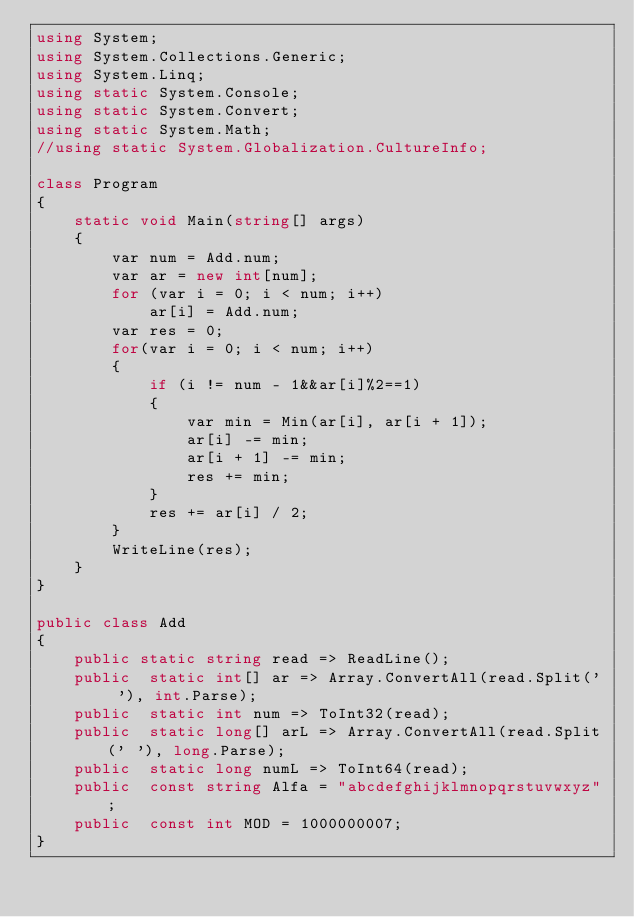Convert code to text. <code><loc_0><loc_0><loc_500><loc_500><_C#_>using System;
using System.Collections.Generic;
using System.Linq;
using static System.Console;
using static System.Convert;
using static System.Math;
//using static System.Globalization.CultureInfo;

class Program
{
    static void Main(string[] args)
    {
        var num = Add.num;
        var ar = new int[num];
        for (var i = 0; i < num; i++)
            ar[i] = Add.num;
        var res = 0;
        for(var i = 0; i < num; i++)
        {
            if (i != num - 1&&ar[i]%2==1)
            {
                var min = Min(ar[i], ar[i + 1]);
                ar[i] -= min;
                ar[i + 1] -= min;
                res += min;
            }
            res += ar[i] / 2;
        }
        WriteLine(res);
    }
}

public class Add
{
    public static string read => ReadLine();
    public  static int[] ar => Array.ConvertAll(read.Split(' '), int.Parse);
    public  static int num => ToInt32(read);
    public  static long[] arL => Array.ConvertAll(read.Split(' '), long.Parse);
    public  static long numL => ToInt64(read);
    public  const string Alfa = "abcdefghijklmnopqrstuvwxyz";
    public  const int MOD = 1000000007;
}
</code> 